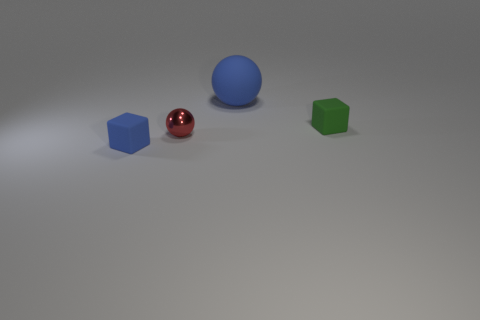Are any tiny green metallic cylinders visible?
Provide a succinct answer. No. How many things are cubes that are left of the green thing or small gray metallic things?
Offer a very short reply. 1. There is a ball that is the same size as the green matte object; what material is it?
Your response must be concise. Metal. What is the color of the block that is right of the blue object that is in front of the blue rubber ball?
Your answer should be compact. Green. There is a large rubber thing; what number of cubes are left of it?
Your response must be concise. 1. What color is the tiny shiny sphere?
Offer a terse response. Red. How many large objects are either red metal cylinders or red things?
Offer a very short reply. 0. Do the rubber ball that is behind the small red metallic ball and the tiny object that is on the left side of the red ball have the same color?
Keep it short and to the point. Yes. How many other things are the same color as the large matte ball?
Offer a very short reply. 1. There is a tiny matte thing behind the small blue rubber thing; what shape is it?
Provide a short and direct response. Cube. 